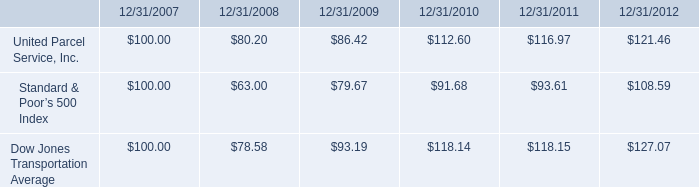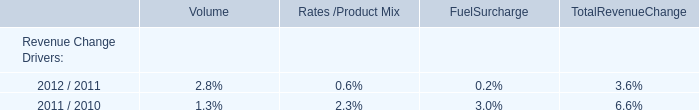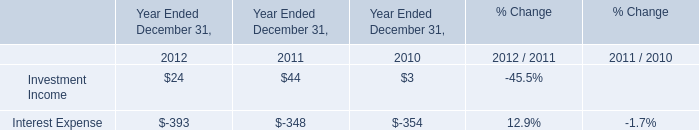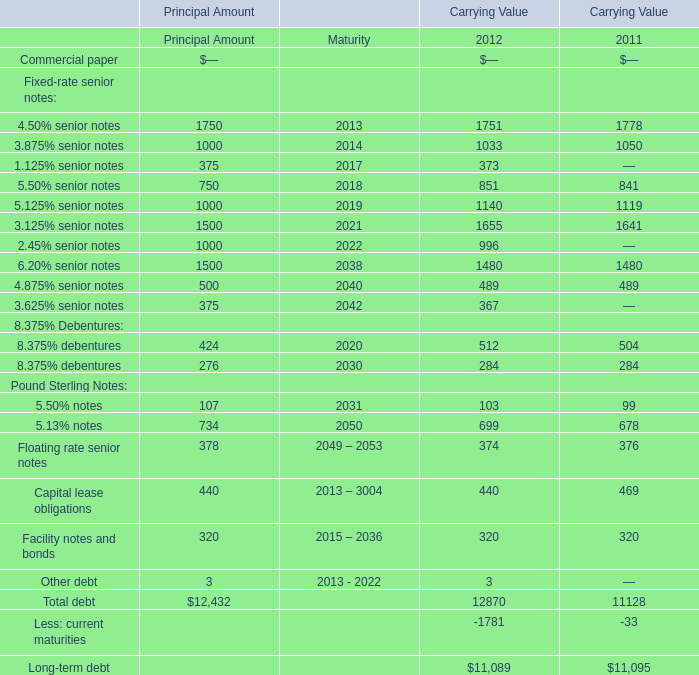What is the sum of the 4.50% senior notes in the years where 4.50% senior notes is positive? 
Computations: (1751 + 1778)
Answer: 3529.0. 